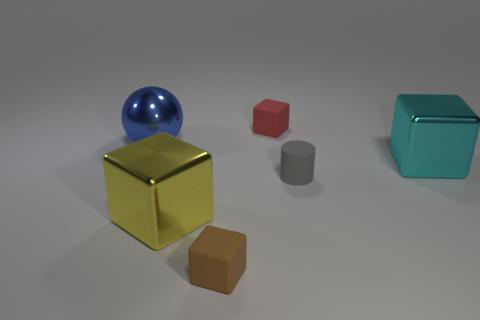Subtract all yellow cubes. How many cubes are left? 3 Add 2 blue shiny balls. How many objects exist? 8 Subtract 2 cubes. How many cubes are left? 2 Subtract all big cyan cubes. How many cubes are left? 3 Subtract all gray blocks. Subtract all yellow balls. How many blocks are left? 4 Subtract all balls. How many objects are left? 5 Subtract all gray spheres. Subtract all big blue metallic things. How many objects are left? 5 Add 1 gray rubber objects. How many gray rubber objects are left? 2 Add 5 tiny red cubes. How many tiny red cubes exist? 6 Subtract 0 green spheres. How many objects are left? 6 